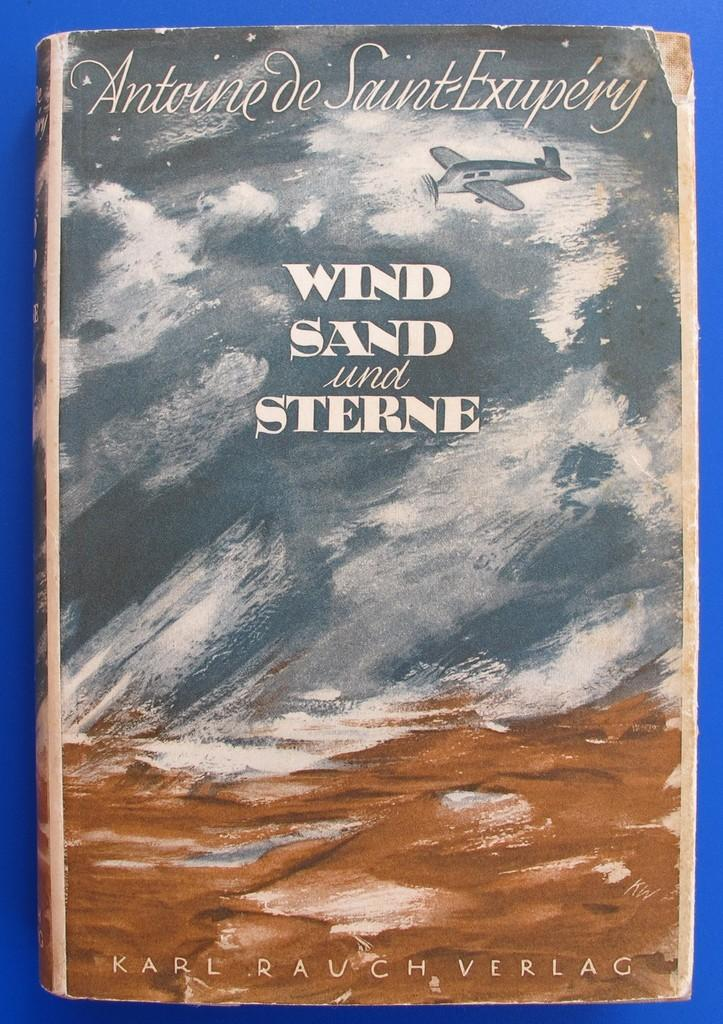<image>
Share a concise interpretation of the image provided. a wind, sand and sterne book by Karl Rauch Verlag 